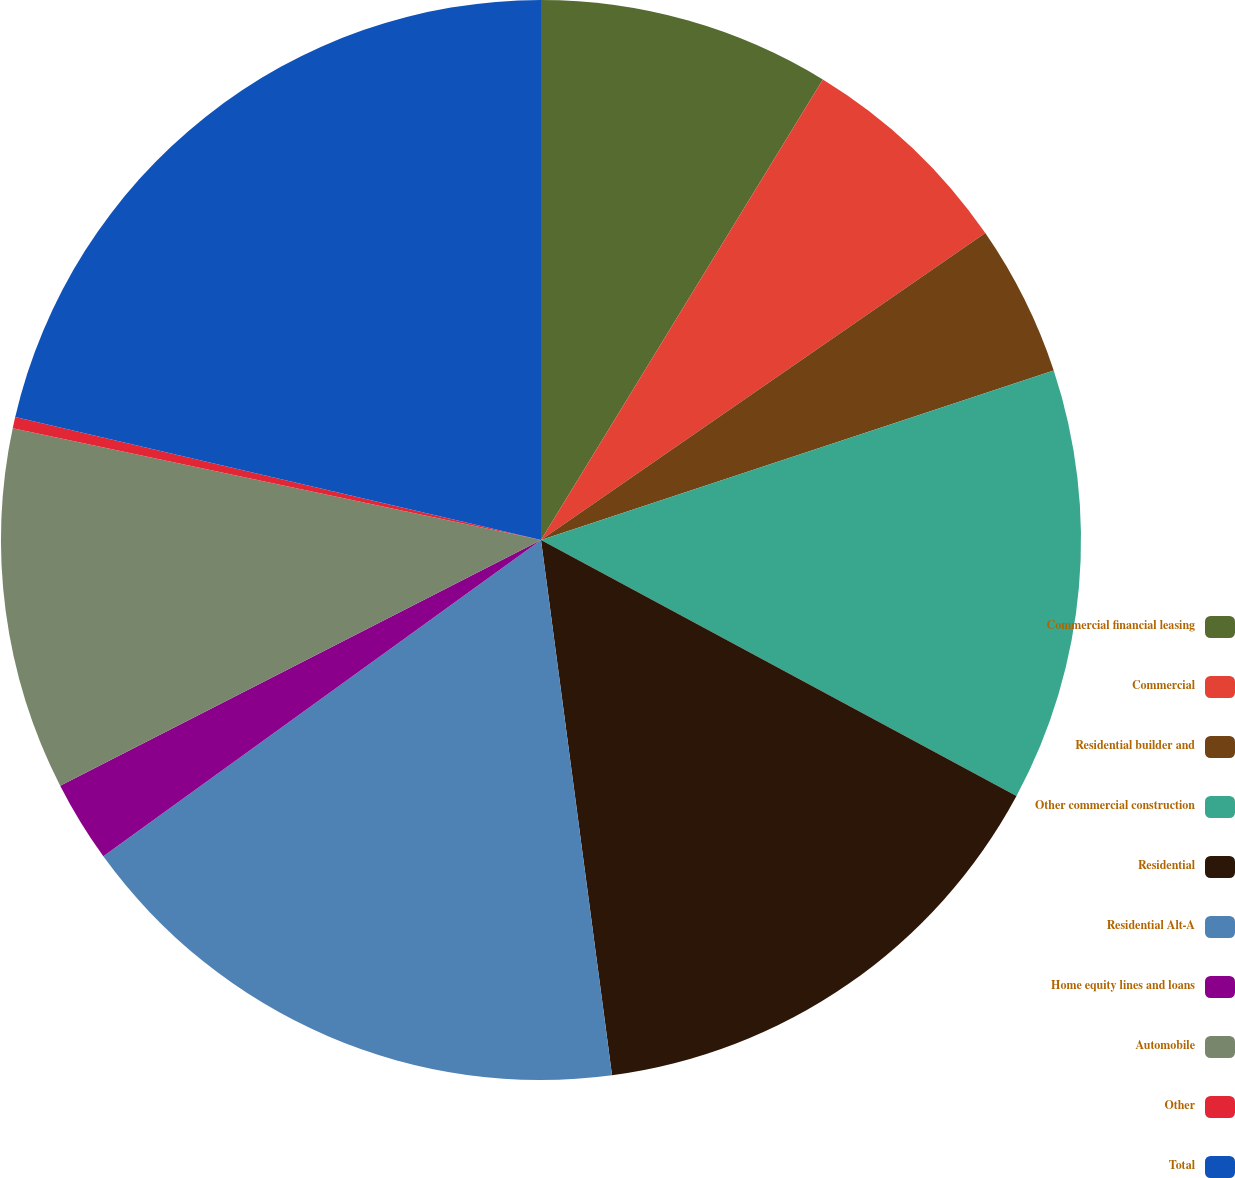Convert chart to OTSL. <chart><loc_0><loc_0><loc_500><loc_500><pie_chart><fcel>Commercial financial leasing<fcel>Commercial<fcel>Residential builder and<fcel>Other commercial construction<fcel>Residential<fcel>Residential Alt-A<fcel>Home equity lines and loans<fcel>Automobile<fcel>Other<fcel>Total<nl><fcel>8.74%<fcel>6.64%<fcel>4.54%<fcel>12.94%<fcel>15.04%<fcel>17.14%<fcel>2.44%<fcel>10.84%<fcel>0.34%<fcel>21.34%<nl></chart> 